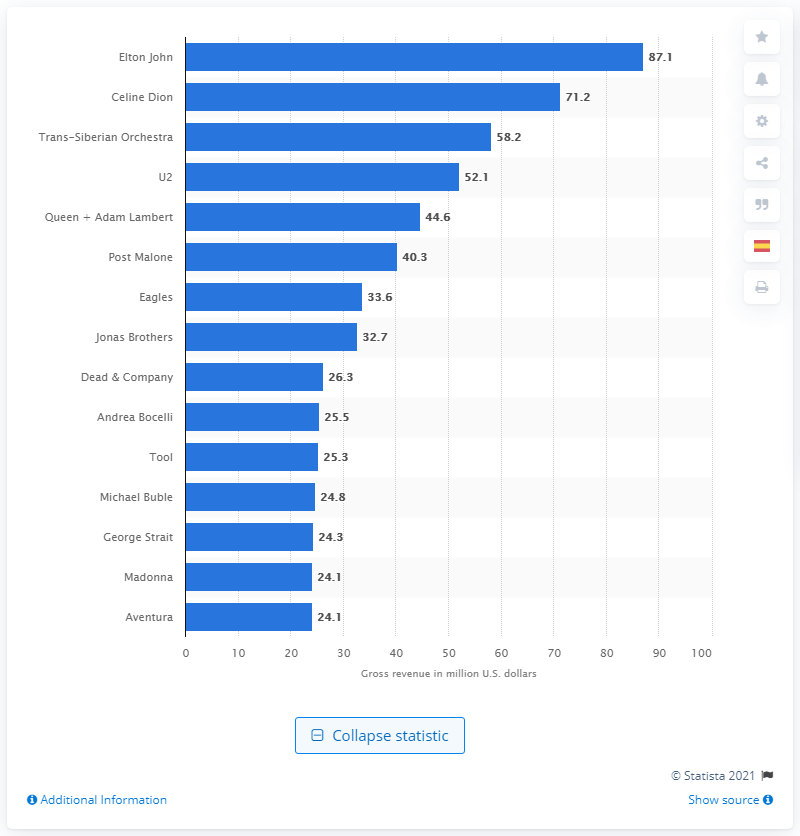Draw attention to some important aspects in this diagram. Elton John's 2020 tour grossed a total of 87.1 million dollars in revenue. In 2020, Elton John was at the top of the list of the most successful worldwide tours. 